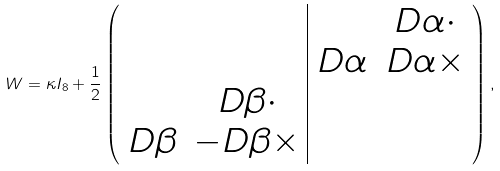<formula> <loc_0><loc_0><loc_500><loc_500>W = \kappa I _ { 8 } + \frac { 1 } { 2 } \left ( \begin{array} { c c | c c } & & & D \alpha \cdot \\ & & D \alpha & D \alpha \times \\ & D \beta \cdot & & \\ D \beta & - D \beta \times & & \\ \end{array} \right ) ,</formula> 